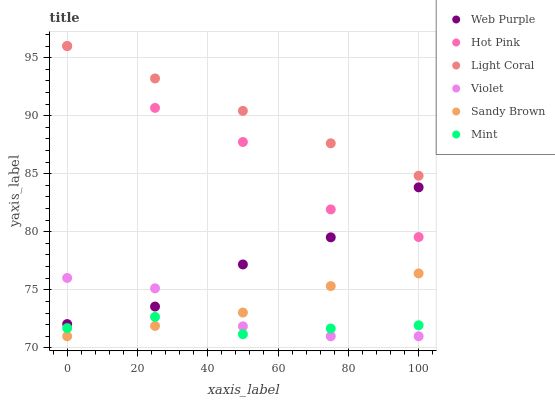Does Mint have the minimum area under the curve?
Answer yes or no. Yes. Does Light Coral have the maximum area under the curve?
Answer yes or no. Yes. Does Hot Pink have the minimum area under the curve?
Answer yes or no. No. Does Hot Pink have the maximum area under the curve?
Answer yes or no. No. Is Light Coral the smoothest?
Answer yes or no. Yes. Is Hot Pink the roughest?
Answer yes or no. Yes. Is Hot Pink the smoothest?
Answer yes or no. No. Is Light Coral the roughest?
Answer yes or no. No. Does Sandy Brown have the lowest value?
Answer yes or no. Yes. Does Hot Pink have the lowest value?
Answer yes or no. No. Does Light Coral have the highest value?
Answer yes or no. Yes. Does Web Purple have the highest value?
Answer yes or no. No. Is Mint less than Light Coral?
Answer yes or no. Yes. Is Web Purple greater than Mint?
Answer yes or no. Yes. Does Hot Pink intersect Light Coral?
Answer yes or no. Yes. Is Hot Pink less than Light Coral?
Answer yes or no. No. Is Hot Pink greater than Light Coral?
Answer yes or no. No. Does Mint intersect Light Coral?
Answer yes or no. No. 